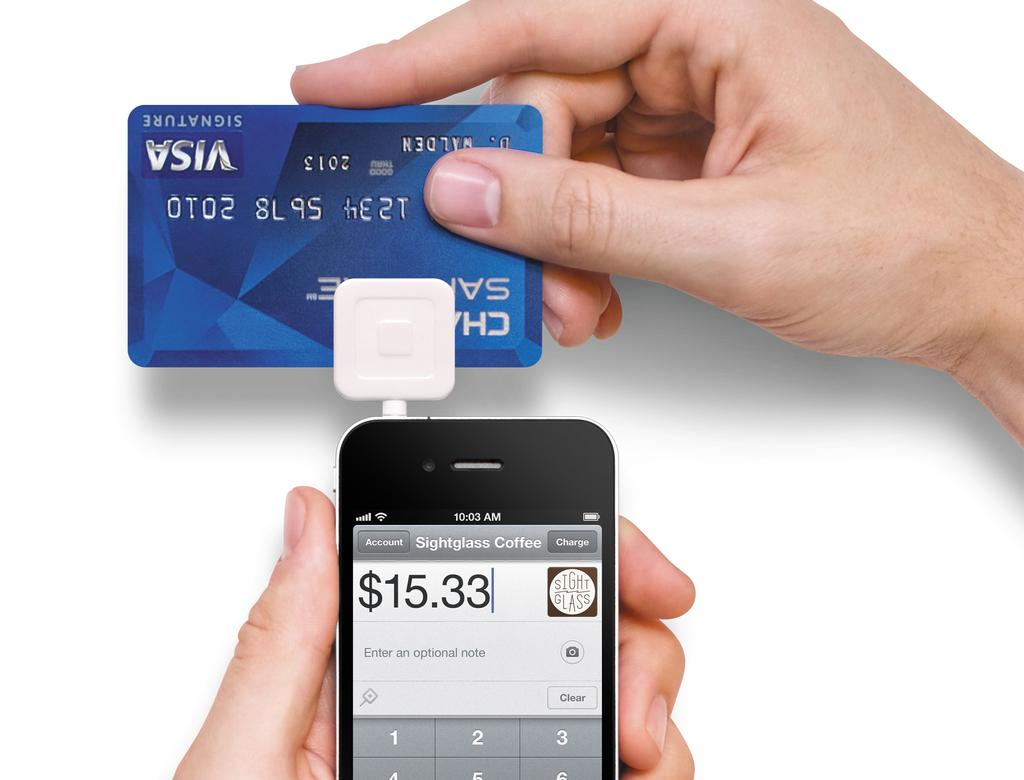<image>
Relay a brief, clear account of the picture shown. a phone that has 15.33 on it with a blue card 